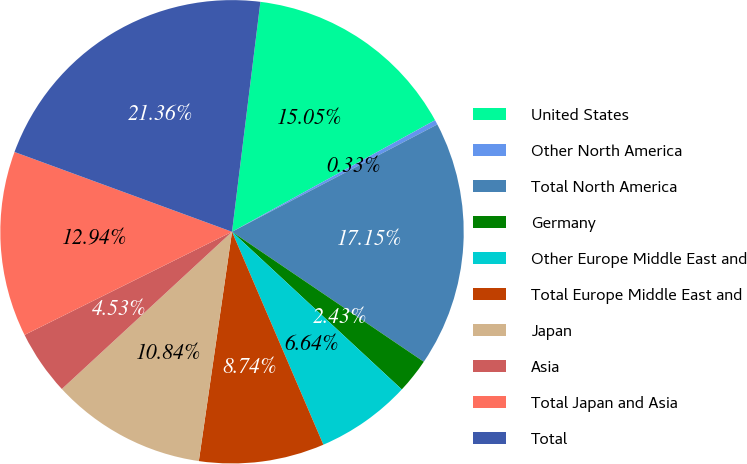Convert chart to OTSL. <chart><loc_0><loc_0><loc_500><loc_500><pie_chart><fcel>United States<fcel>Other North America<fcel>Total North America<fcel>Germany<fcel>Other Europe Middle East and<fcel>Total Europe Middle East and<fcel>Japan<fcel>Asia<fcel>Total Japan and Asia<fcel>Total<nl><fcel>15.05%<fcel>0.33%<fcel>17.15%<fcel>2.43%<fcel>6.64%<fcel>8.74%<fcel>10.84%<fcel>4.53%<fcel>12.94%<fcel>21.36%<nl></chart> 